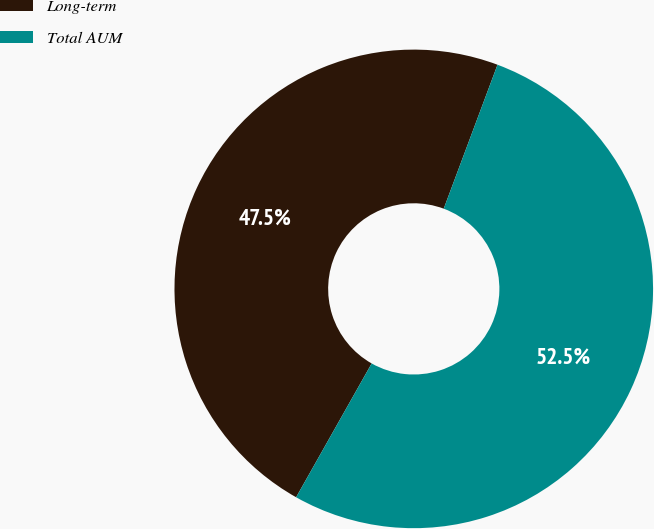Convert chart. <chart><loc_0><loc_0><loc_500><loc_500><pie_chart><fcel>Long-term<fcel>Total AUM<nl><fcel>47.51%<fcel>52.49%<nl></chart> 